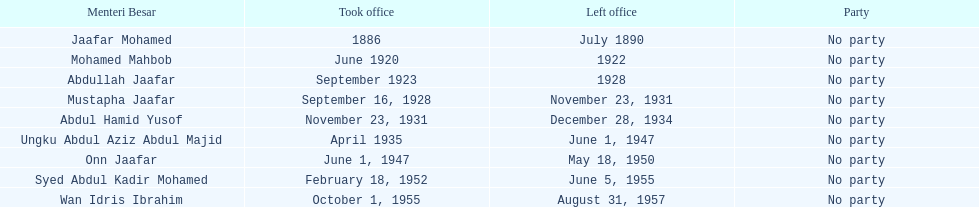What was the date the last person on the list left office? August 31, 1957. 